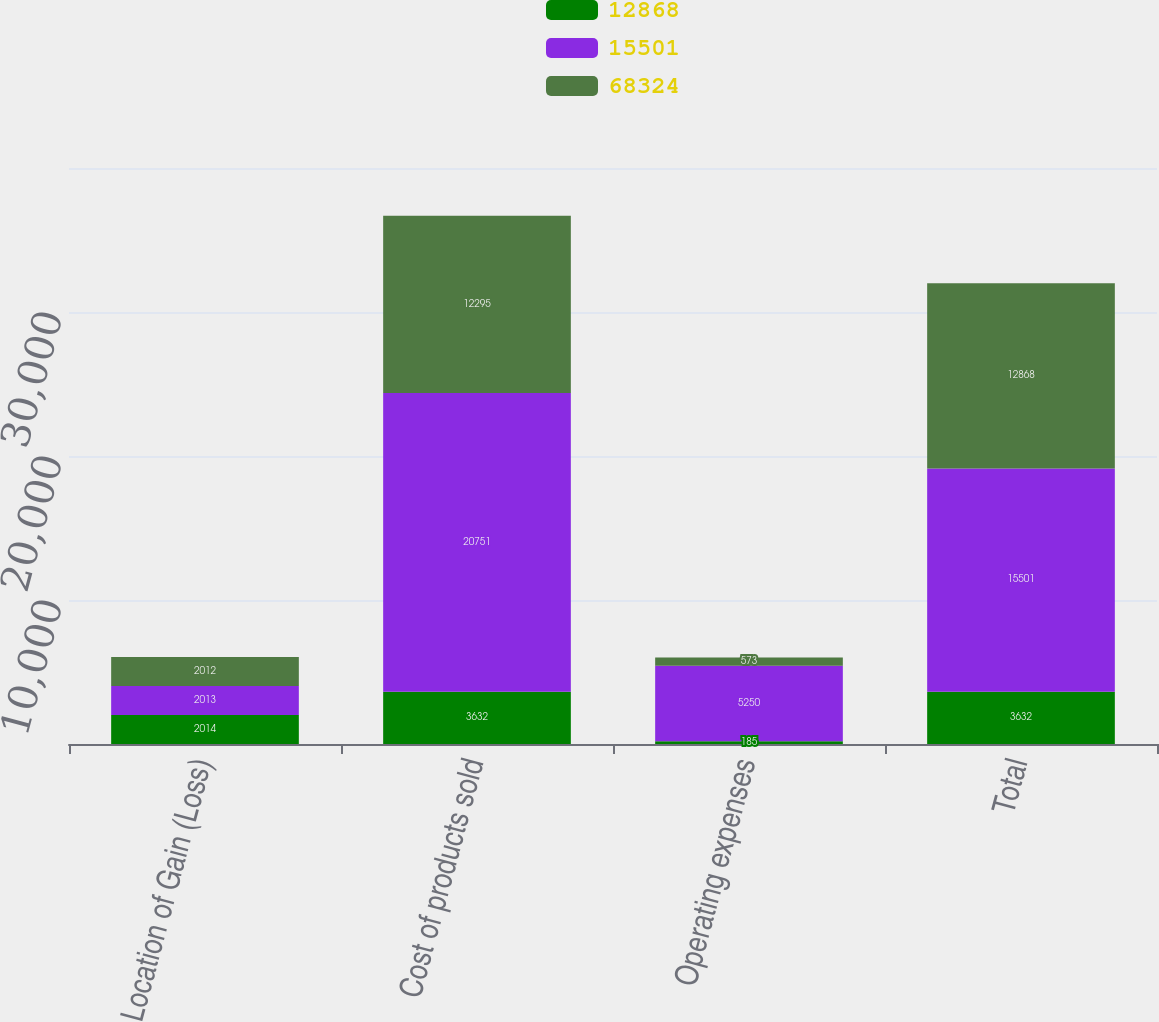Convert chart. <chart><loc_0><loc_0><loc_500><loc_500><stacked_bar_chart><ecel><fcel>Location of Gain (Loss)<fcel>Cost of products sold<fcel>Operating expenses<fcel>Total<nl><fcel>12868<fcel>2014<fcel>3632<fcel>185<fcel>3632<nl><fcel>15501<fcel>2013<fcel>20751<fcel>5250<fcel>15501<nl><fcel>68324<fcel>2012<fcel>12295<fcel>573<fcel>12868<nl></chart> 